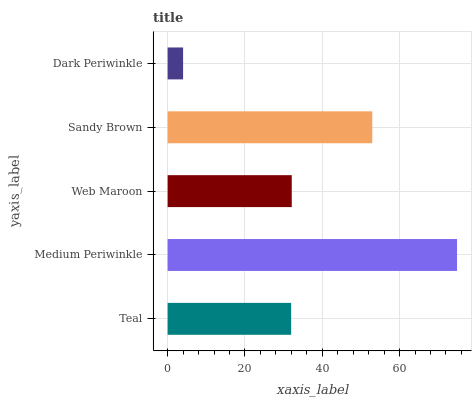Is Dark Periwinkle the minimum?
Answer yes or no. Yes. Is Medium Periwinkle the maximum?
Answer yes or no. Yes. Is Web Maroon the minimum?
Answer yes or no. No. Is Web Maroon the maximum?
Answer yes or no. No. Is Medium Periwinkle greater than Web Maroon?
Answer yes or no. Yes. Is Web Maroon less than Medium Periwinkle?
Answer yes or no. Yes. Is Web Maroon greater than Medium Periwinkle?
Answer yes or no. No. Is Medium Periwinkle less than Web Maroon?
Answer yes or no. No. Is Web Maroon the high median?
Answer yes or no. Yes. Is Web Maroon the low median?
Answer yes or no. Yes. Is Sandy Brown the high median?
Answer yes or no. No. Is Medium Periwinkle the low median?
Answer yes or no. No. 